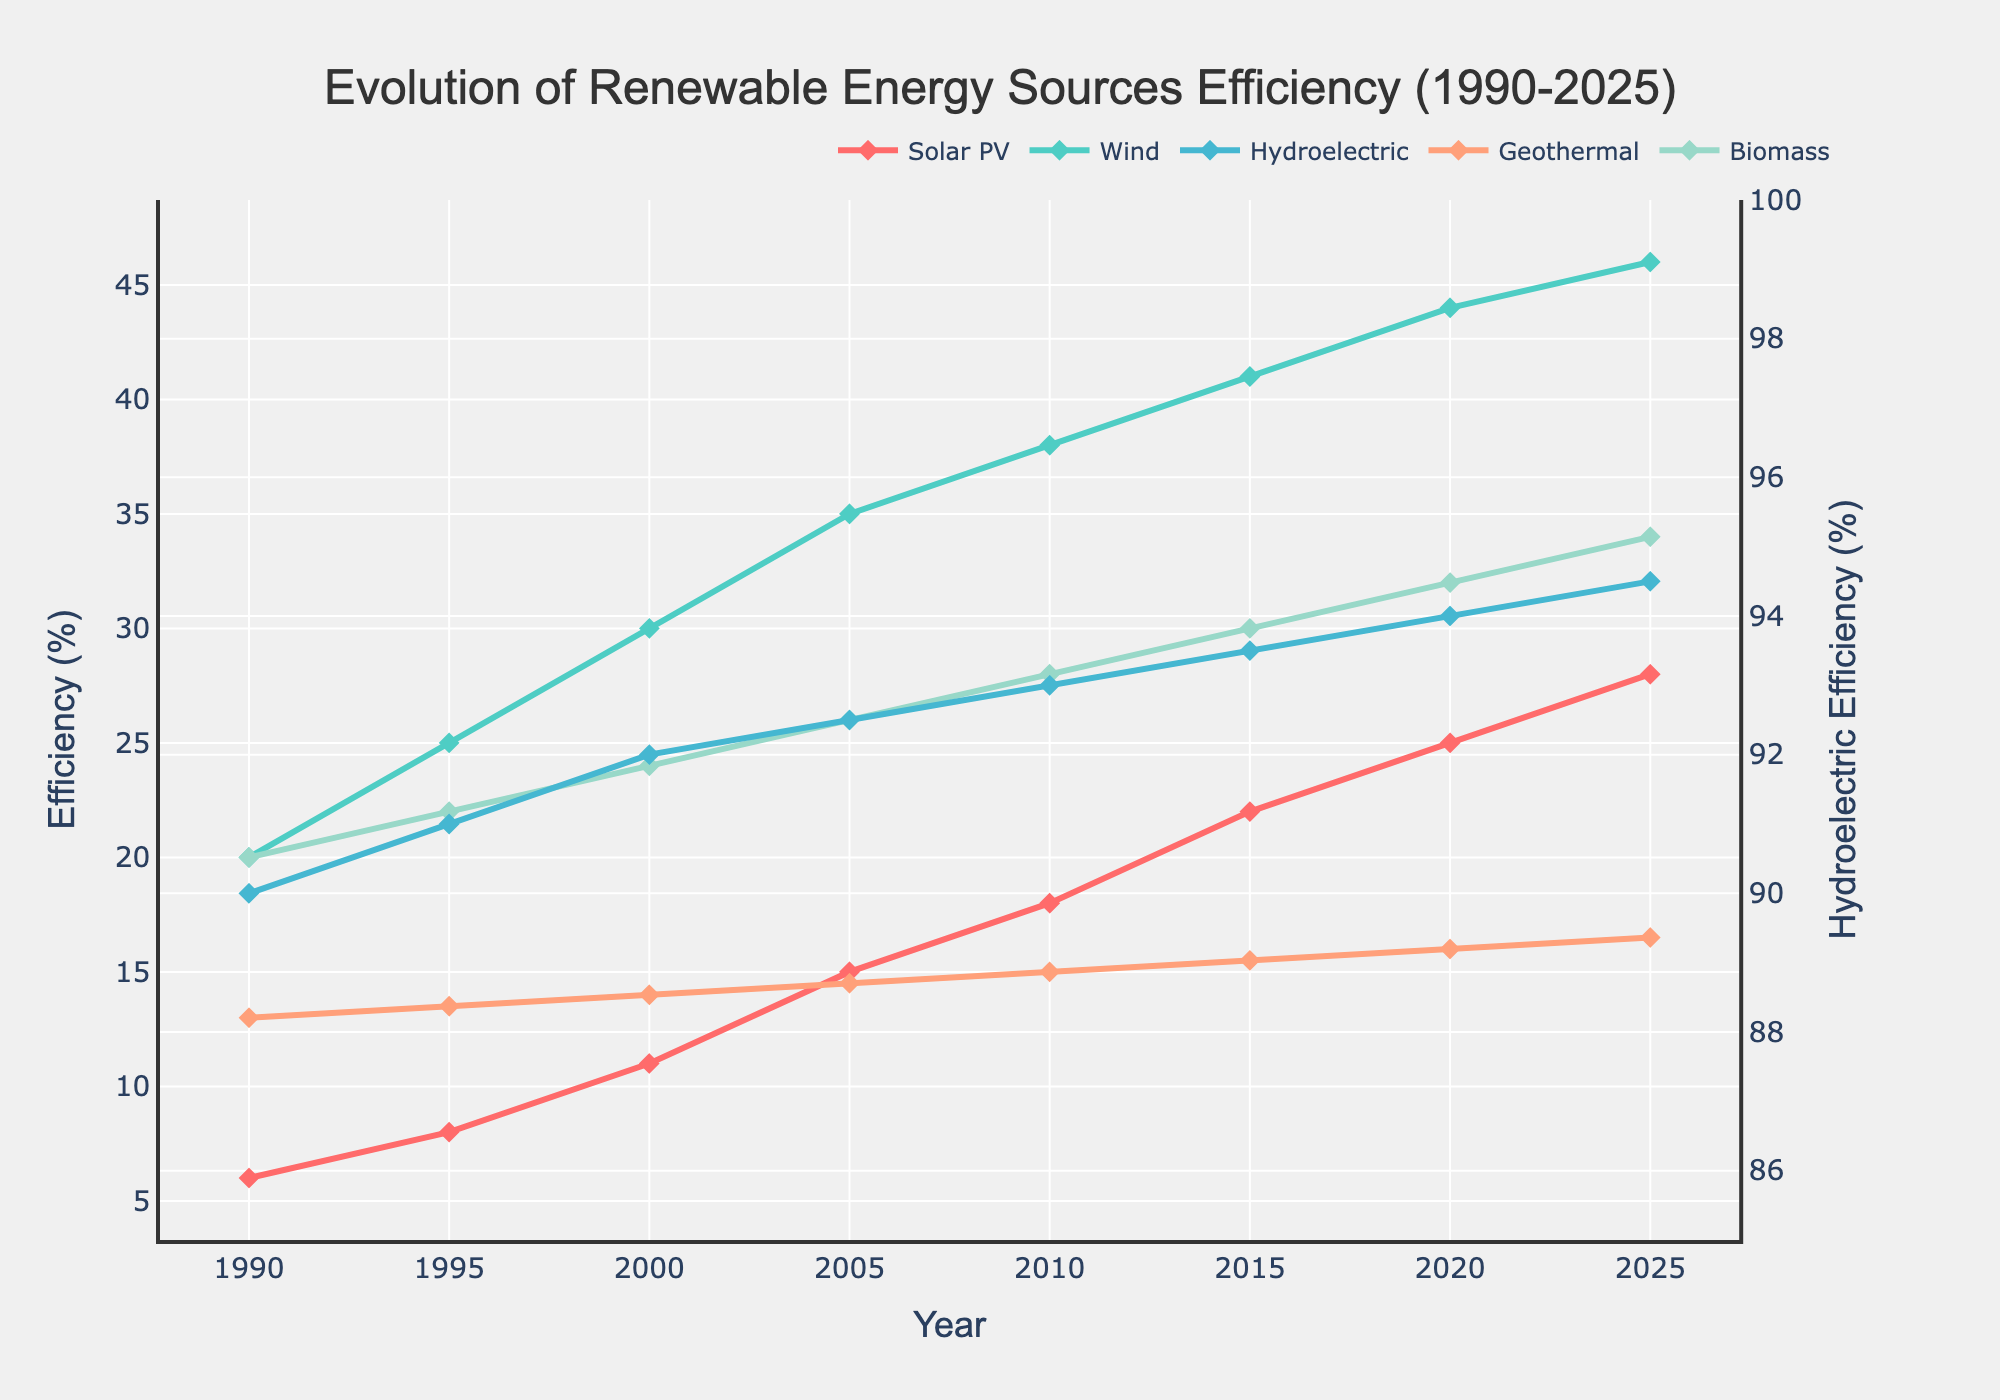What's the trend of Solar PV efficiency from 1990 to 2025? The efficiency rate of Solar PV shows a consistent increase from 6% in 1990 to 28% in 2025.
Answer: Increasing In 2010, which renewable energy source had the highest efficiency? In the year 2010, Hydroelectric had the highest efficiency at 93%.
Answer: Hydroelectric By how much did Wind efficiency increase from 1990 to 2025? Wind efficiency increased from 20% in 1990 to 46% in 2025. The difference is 46 - 20 = 26%.
Answer: 26% Compare the trend of Solar PV and Biomass from 1990 to 2025. Which one increased more? Solar PV increased more, from 6% to 28% (22% increase), whereas Biomass increased from 20% to 34% (14% increase).
Answer: Solar PV What is the difference in efficiency between Solar PV and Geothermal in 2020? In 2020, Solar PV had an efficiency of 25%, and Geothermal had 16%. The difference is 25 - 16 = 9%.
Answer: 9% What has been the average efficiency of Wind energy over all the given years? Summing efficiencies of Wind for each year: 20 + 25 + 30 + 35 + 38 + 41 + 44 + 46 = 279. There are 8 years, so the average is 279 / 8 = 34.875%.
Answer: 34.875% Which renewable energy source has the least variation in efficiency over time? Hydroelectric efficiency has the least variation, fluctuating narrowly from 90% in 1990 to 94.5% in 2025.
Answer: Hydroelectric What is the efficiency rate of Geothermal energy in 1995? The efficiency rate of Geothermal energy in 1995 is shown at 13.5%.
Answer: 13.5% How does the efficiency of Biomass compare to Geothermal in 2005? In 2005, Biomass efficiency is at 26% while Geothermal is at 14.5%. Biomass is higher by 26 - 14.5 = 11.5%.
Answer: Biomass is higher by 11.5% 